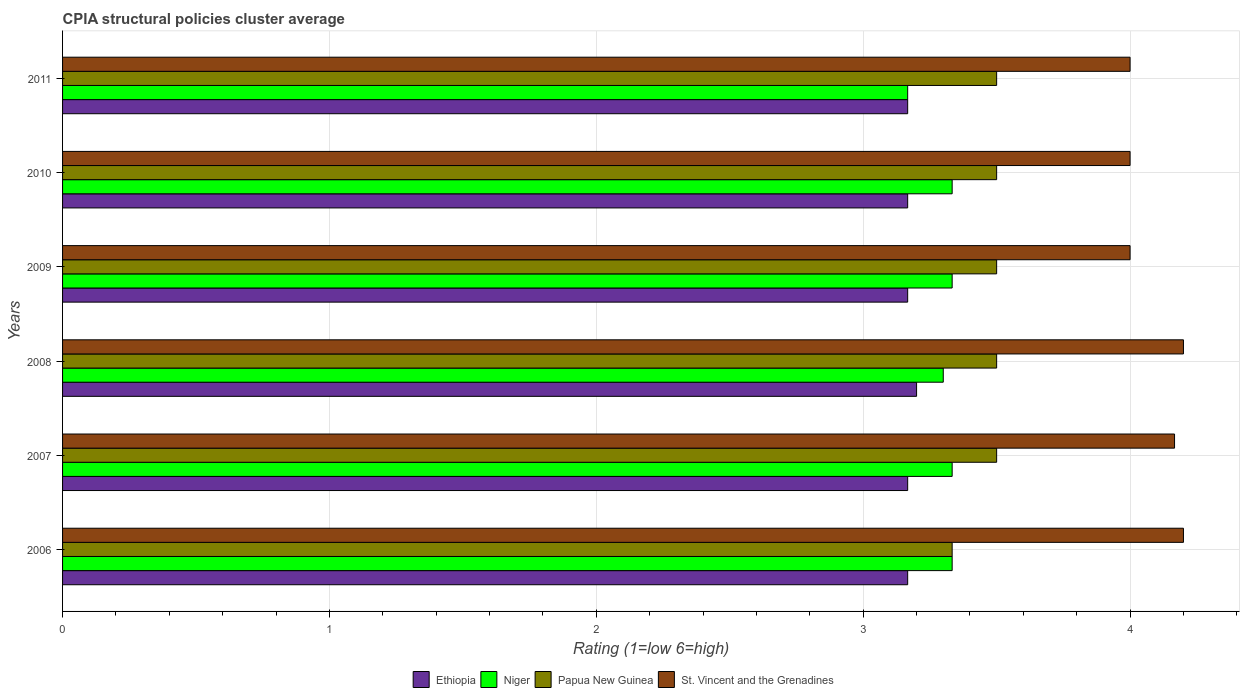How many different coloured bars are there?
Your answer should be compact. 4. What is the label of the 2nd group of bars from the top?
Keep it short and to the point. 2010. What is the CPIA rating in Papua New Guinea in 2006?
Provide a succinct answer. 3.33. Across all years, what is the maximum CPIA rating in Ethiopia?
Your answer should be compact. 3.2. Across all years, what is the minimum CPIA rating in St. Vincent and the Grenadines?
Offer a terse response. 4. In which year was the CPIA rating in Ethiopia maximum?
Your answer should be compact. 2008. In which year was the CPIA rating in St. Vincent and the Grenadines minimum?
Provide a succinct answer. 2009. What is the total CPIA rating in St. Vincent and the Grenadines in the graph?
Ensure brevity in your answer.  24.57. What is the difference between the CPIA rating in St. Vincent and the Grenadines in 2006 and that in 2011?
Keep it short and to the point. 0.2. What is the average CPIA rating in Papua New Guinea per year?
Your answer should be compact. 3.47. In the year 2011, what is the difference between the CPIA rating in Papua New Guinea and CPIA rating in Niger?
Your answer should be very brief. 0.33. In how many years, is the CPIA rating in Ethiopia greater than 2.6 ?
Your answer should be very brief. 6. What is the ratio of the CPIA rating in Papua New Guinea in 2006 to that in 2008?
Offer a very short reply. 0.95. Is the CPIA rating in St. Vincent and the Grenadines in 2008 less than that in 2009?
Provide a short and direct response. No. Is the difference between the CPIA rating in Papua New Guinea in 2009 and 2011 greater than the difference between the CPIA rating in Niger in 2009 and 2011?
Give a very brief answer. No. What is the difference between the highest and the second highest CPIA rating in St. Vincent and the Grenadines?
Provide a succinct answer. 0. What is the difference between the highest and the lowest CPIA rating in St. Vincent and the Grenadines?
Your response must be concise. 0.2. In how many years, is the CPIA rating in Papua New Guinea greater than the average CPIA rating in Papua New Guinea taken over all years?
Offer a terse response. 5. Is the sum of the CPIA rating in Ethiopia in 2007 and 2008 greater than the maximum CPIA rating in St. Vincent and the Grenadines across all years?
Make the answer very short. Yes. What does the 4th bar from the top in 2011 represents?
Ensure brevity in your answer.  Ethiopia. What does the 3rd bar from the bottom in 2006 represents?
Your response must be concise. Papua New Guinea. Is it the case that in every year, the sum of the CPIA rating in St. Vincent and the Grenadines and CPIA rating in Ethiopia is greater than the CPIA rating in Niger?
Give a very brief answer. Yes. What is the difference between two consecutive major ticks on the X-axis?
Give a very brief answer. 1. Are the values on the major ticks of X-axis written in scientific E-notation?
Offer a terse response. No. Does the graph contain any zero values?
Offer a terse response. No. Does the graph contain grids?
Your response must be concise. Yes. Where does the legend appear in the graph?
Offer a very short reply. Bottom center. How many legend labels are there?
Make the answer very short. 4. How are the legend labels stacked?
Make the answer very short. Horizontal. What is the title of the graph?
Provide a short and direct response. CPIA structural policies cluster average. Does "Jordan" appear as one of the legend labels in the graph?
Your response must be concise. No. What is the label or title of the X-axis?
Make the answer very short. Rating (1=low 6=high). What is the label or title of the Y-axis?
Make the answer very short. Years. What is the Rating (1=low 6=high) of Ethiopia in 2006?
Make the answer very short. 3.17. What is the Rating (1=low 6=high) in Niger in 2006?
Ensure brevity in your answer.  3.33. What is the Rating (1=low 6=high) of Papua New Guinea in 2006?
Give a very brief answer. 3.33. What is the Rating (1=low 6=high) in Ethiopia in 2007?
Provide a succinct answer. 3.17. What is the Rating (1=low 6=high) in Niger in 2007?
Give a very brief answer. 3.33. What is the Rating (1=low 6=high) of Papua New Guinea in 2007?
Offer a terse response. 3.5. What is the Rating (1=low 6=high) of St. Vincent and the Grenadines in 2007?
Provide a succinct answer. 4.17. What is the Rating (1=low 6=high) in Papua New Guinea in 2008?
Give a very brief answer. 3.5. What is the Rating (1=low 6=high) of St. Vincent and the Grenadines in 2008?
Your answer should be very brief. 4.2. What is the Rating (1=low 6=high) in Ethiopia in 2009?
Keep it short and to the point. 3.17. What is the Rating (1=low 6=high) of Niger in 2009?
Offer a terse response. 3.33. What is the Rating (1=low 6=high) in Papua New Guinea in 2009?
Your response must be concise. 3.5. What is the Rating (1=low 6=high) of Ethiopia in 2010?
Your answer should be compact. 3.17. What is the Rating (1=low 6=high) of Niger in 2010?
Your answer should be very brief. 3.33. What is the Rating (1=low 6=high) in Papua New Guinea in 2010?
Offer a terse response. 3.5. What is the Rating (1=low 6=high) of Ethiopia in 2011?
Provide a succinct answer. 3.17. What is the Rating (1=low 6=high) of Niger in 2011?
Offer a very short reply. 3.17. Across all years, what is the maximum Rating (1=low 6=high) of Niger?
Ensure brevity in your answer.  3.33. Across all years, what is the maximum Rating (1=low 6=high) of Papua New Guinea?
Your answer should be compact. 3.5. Across all years, what is the maximum Rating (1=low 6=high) in St. Vincent and the Grenadines?
Your response must be concise. 4.2. Across all years, what is the minimum Rating (1=low 6=high) of Ethiopia?
Your response must be concise. 3.17. Across all years, what is the minimum Rating (1=low 6=high) of Niger?
Make the answer very short. 3.17. Across all years, what is the minimum Rating (1=low 6=high) of Papua New Guinea?
Your answer should be very brief. 3.33. Across all years, what is the minimum Rating (1=low 6=high) in St. Vincent and the Grenadines?
Offer a terse response. 4. What is the total Rating (1=low 6=high) of Ethiopia in the graph?
Make the answer very short. 19.03. What is the total Rating (1=low 6=high) in Niger in the graph?
Your answer should be compact. 19.8. What is the total Rating (1=low 6=high) in Papua New Guinea in the graph?
Your answer should be very brief. 20.83. What is the total Rating (1=low 6=high) in St. Vincent and the Grenadines in the graph?
Ensure brevity in your answer.  24.57. What is the difference between the Rating (1=low 6=high) of Ethiopia in 2006 and that in 2007?
Ensure brevity in your answer.  0. What is the difference between the Rating (1=low 6=high) in St. Vincent and the Grenadines in 2006 and that in 2007?
Give a very brief answer. 0.03. What is the difference between the Rating (1=low 6=high) of Ethiopia in 2006 and that in 2008?
Give a very brief answer. -0.03. What is the difference between the Rating (1=low 6=high) of Papua New Guinea in 2006 and that in 2008?
Offer a very short reply. -0.17. What is the difference between the Rating (1=low 6=high) of Niger in 2006 and that in 2009?
Provide a succinct answer. 0. What is the difference between the Rating (1=low 6=high) in Niger in 2006 and that in 2010?
Your answer should be compact. 0. What is the difference between the Rating (1=low 6=high) in Papua New Guinea in 2006 and that in 2010?
Your answer should be very brief. -0.17. What is the difference between the Rating (1=low 6=high) in St. Vincent and the Grenadines in 2006 and that in 2010?
Your response must be concise. 0.2. What is the difference between the Rating (1=low 6=high) of Ethiopia in 2007 and that in 2008?
Give a very brief answer. -0.03. What is the difference between the Rating (1=low 6=high) in Niger in 2007 and that in 2008?
Provide a succinct answer. 0.03. What is the difference between the Rating (1=low 6=high) in Papua New Guinea in 2007 and that in 2008?
Provide a succinct answer. 0. What is the difference between the Rating (1=low 6=high) in St. Vincent and the Grenadines in 2007 and that in 2008?
Provide a succinct answer. -0.03. What is the difference between the Rating (1=low 6=high) of Ethiopia in 2007 and that in 2009?
Your response must be concise. 0. What is the difference between the Rating (1=low 6=high) of Niger in 2007 and that in 2009?
Keep it short and to the point. 0. What is the difference between the Rating (1=low 6=high) in Papua New Guinea in 2007 and that in 2009?
Offer a very short reply. 0. What is the difference between the Rating (1=low 6=high) of St. Vincent and the Grenadines in 2007 and that in 2009?
Keep it short and to the point. 0.17. What is the difference between the Rating (1=low 6=high) in Niger in 2007 and that in 2010?
Offer a very short reply. 0. What is the difference between the Rating (1=low 6=high) in St. Vincent and the Grenadines in 2007 and that in 2010?
Offer a terse response. 0.17. What is the difference between the Rating (1=low 6=high) in Ethiopia in 2007 and that in 2011?
Your answer should be very brief. 0. What is the difference between the Rating (1=low 6=high) in St. Vincent and the Grenadines in 2007 and that in 2011?
Your answer should be compact. 0.17. What is the difference between the Rating (1=low 6=high) in Ethiopia in 2008 and that in 2009?
Offer a terse response. 0.03. What is the difference between the Rating (1=low 6=high) of Niger in 2008 and that in 2009?
Your response must be concise. -0.03. What is the difference between the Rating (1=low 6=high) of Papua New Guinea in 2008 and that in 2009?
Provide a short and direct response. 0. What is the difference between the Rating (1=low 6=high) of St. Vincent and the Grenadines in 2008 and that in 2009?
Offer a very short reply. 0.2. What is the difference between the Rating (1=low 6=high) in Ethiopia in 2008 and that in 2010?
Offer a terse response. 0.03. What is the difference between the Rating (1=low 6=high) in Niger in 2008 and that in 2010?
Your answer should be compact. -0.03. What is the difference between the Rating (1=low 6=high) of Papua New Guinea in 2008 and that in 2010?
Your answer should be compact. 0. What is the difference between the Rating (1=low 6=high) in St. Vincent and the Grenadines in 2008 and that in 2010?
Your response must be concise. 0.2. What is the difference between the Rating (1=low 6=high) in Niger in 2008 and that in 2011?
Your response must be concise. 0.13. What is the difference between the Rating (1=low 6=high) of St. Vincent and the Grenadines in 2008 and that in 2011?
Ensure brevity in your answer.  0.2. What is the difference between the Rating (1=low 6=high) of Ethiopia in 2009 and that in 2010?
Offer a very short reply. 0. What is the difference between the Rating (1=low 6=high) of Niger in 2009 and that in 2010?
Provide a short and direct response. 0. What is the difference between the Rating (1=low 6=high) in Niger in 2009 and that in 2011?
Give a very brief answer. 0.17. What is the difference between the Rating (1=low 6=high) in Papua New Guinea in 2009 and that in 2011?
Your response must be concise. 0. What is the difference between the Rating (1=low 6=high) of St. Vincent and the Grenadines in 2009 and that in 2011?
Offer a very short reply. 0. What is the difference between the Rating (1=low 6=high) of Ethiopia in 2006 and the Rating (1=low 6=high) of St. Vincent and the Grenadines in 2007?
Keep it short and to the point. -1. What is the difference between the Rating (1=low 6=high) in Niger in 2006 and the Rating (1=low 6=high) in Papua New Guinea in 2007?
Provide a succinct answer. -0.17. What is the difference between the Rating (1=low 6=high) of Niger in 2006 and the Rating (1=low 6=high) of St. Vincent and the Grenadines in 2007?
Provide a succinct answer. -0.83. What is the difference between the Rating (1=low 6=high) in Papua New Guinea in 2006 and the Rating (1=low 6=high) in St. Vincent and the Grenadines in 2007?
Provide a succinct answer. -0.83. What is the difference between the Rating (1=low 6=high) in Ethiopia in 2006 and the Rating (1=low 6=high) in Niger in 2008?
Keep it short and to the point. -0.13. What is the difference between the Rating (1=low 6=high) of Ethiopia in 2006 and the Rating (1=low 6=high) of St. Vincent and the Grenadines in 2008?
Your response must be concise. -1.03. What is the difference between the Rating (1=low 6=high) in Niger in 2006 and the Rating (1=low 6=high) in St. Vincent and the Grenadines in 2008?
Offer a very short reply. -0.87. What is the difference between the Rating (1=low 6=high) of Papua New Guinea in 2006 and the Rating (1=low 6=high) of St. Vincent and the Grenadines in 2008?
Your response must be concise. -0.87. What is the difference between the Rating (1=low 6=high) in Ethiopia in 2006 and the Rating (1=low 6=high) in Papua New Guinea in 2009?
Offer a terse response. -0.33. What is the difference between the Rating (1=low 6=high) of Papua New Guinea in 2006 and the Rating (1=low 6=high) of St. Vincent and the Grenadines in 2009?
Provide a succinct answer. -0.67. What is the difference between the Rating (1=low 6=high) in Ethiopia in 2006 and the Rating (1=low 6=high) in Niger in 2010?
Make the answer very short. -0.17. What is the difference between the Rating (1=low 6=high) of Ethiopia in 2006 and the Rating (1=low 6=high) of Papua New Guinea in 2010?
Provide a succinct answer. -0.33. What is the difference between the Rating (1=low 6=high) in Ethiopia in 2006 and the Rating (1=low 6=high) in St. Vincent and the Grenadines in 2010?
Your response must be concise. -0.83. What is the difference between the Rating (1=low 6=high) of Niger in 2006 and the Rating (1=low 6=high) of St. Vincent and the Grenadines in 2010?
Provide a succinct answer. -0.67. What is the difference between the Rating (1=low 6=high) of Niger in 2006 and the Rating (1=low 6=high) of St. Vincent and the Grenadines in 2011?
Keep it short and to the point. -0.67. What is the difference between the Rating (1=low 6=high) in Ethiopia in 2007 and the Rating (1=low 6=high) in Niger in 2008?
Give a very brief answer. -0.13. What is the difference between the Rating (1=low 6=high) of Ethiopia in 2007 and the Rating (1=low 6=high) of Papua New Guinea in 2008?
Provide a short and direct response. -0.33. What is the difference between the Rating (1=low 6=high) of Ethiopia in 2007 and the Rating (1=low 6=high) of St. Vincent and the Grenadines in 2008?
Offer a terse response. -1.03. What is the difference between the Rating (1=low 6=high) of Niger in 2007 and the Rating (1=low 6=high) of St. Vincent and the Grenadines in 2008?
Offer a very short reply. -0.87. What is the difference between the Rating (1=low 6=high) in Ethiopia in 2007 and the Rating (1=low 6=high) in Papua New Guinea in 2009?
Offer a very short reply. -0.33. What is the difference between the Rating (1=low 6=high) of Niger in 2007 and the Rating (1=low 6=high) of Papua New Guinea in 2009?
Provide a succinct answer. -0.17. What is the difference between the Rating (1=low 6=high) of Ethiopia in 2007 and the Rating (1=low 6=high) of St. Vincent and the Grenadines in 2010?
Give a very brief answer. -0.83. What is the difference between the Rating (1=low 6=high) in Papua New Guinea in 2007 and the Rating (1=low 6=high) in St. Vincent and the Grenadines in 2010?
Your answer should be very brief. -0.5. What is the difference between the Rating (1=low 6=high) of Ethiopia in 2007 and the Rating (1=low 6=high) of Niger in 2011?
Offer a terse response. 0. What is the difference between the Rating (1=low 6=high) in Niger in 2007 and the Rating (1=low 6=high) in St. Vincent and the Grenadines in 2011?
Offer a terse response. -0.67. What is the difference between the Rating (1=low 6=high) of Ethiopia in 2008 and the Rating (1=low 6=high) of Niger in 2009?
Ensure brevity in your answer.  -0.13. What is the difference between the Rating (1=low 6=high) in Ethiopia in 2008 and the Rating (1=low 6=high) in Niger in 2010?
Make the answer very short. -0.13. What is the difference between the Rating (1=low 6=high) of Ethiopia in 2008 and the Rating (1=low 6=high) of St. Vincent and the Grenadines in 2010?
Your answer should be compact. -0.8. What is the difference between the Rating (1=low 6=high) of Niger in 2008 and the Rating (1=low 6=high) of St. Vincent and the Grenadines in 2010?
Your answer should be compact. -0.7. What is the difference between the Rating (1=low 6=high) of Ethiopia in 2008 and the Rating (1=low 6=high) of Niger in 2011?
Give a very brief answer. 0.03. What is the difference between the Rating (1=low 6=high) in Ethiopia in 2008 and the Rating (1=low 6=high) in Papua New Guinea in 2011?
Your answer should be compact. -0.3. What is the difference between the Rating (1=low 6=high) in Ethiopia in 2008 and the Rating (1=low 6=high) in St. Vincent and the Grenadines in 2011?
Make the answer very short. -0.8. What is the difference between the Rating (1=low 6=high) in Niger in 2008 and the Rating (1=low 6=high) in St. Vincent and the Grenadines in 2011?
Give a very brief answer. -0.7. What is the difference between the Rating (1=low 6=high) of Papua New Guinea in 2008 and the Rating (1=low 6=high) of St. Vincent and the Grenadines in 2011?
Give a very brief answer. -0.5. What is the difference between the Rating (1=low 6=high) in Ethiopia in 2009 and the Rating (1=low 6=high) in Papua New Guinea in 2010?
Your answer should be very brief. -0.33. What is the difference between the Rating (1=low 6=high) in Niger in 2009 and the Rating (1=low 6=high) in Papua New Guinea in 2010?
Provide a short and direct response. -0.17. What is the difference between the Rating (1=low 6=high) of Ethiopia in 2009 and the Rating (1=low 6=high) of Niger in 2011?
Provide a succinct answer. 0. What is the difference between the Rating (1=low 6=high) in Ethiopia in 2009 and the Rating (1=low 6=high) in Papua New Guinea in 2011?
Make the answer very short. -0.33. What is the difference between the Rating (1=low 6=high) of Papua New Guinea in 2009 and the Rating (1=low 6=high) of St. Vincent and the Grenadines in 2011?
Provide a short and direct response. -0.5. What is the difference between the Rating (1=low 6=high) in Ethiopia in 2010 and the Rating (1=low 6=high) in Niger in 2011?
Give a very brief answer. 0. What is the difference between the Rating (1=low 6=high) in Ethiopia in 2010 and the Rating (1=low 6=high) in Papua New Guinea in 2011?
Provide a short and direct response. -0.33. What is the difference between the Rating (1=low 6=high) in Ethiopia in 2010 and the Rating (1=low 6=high) in St. Vincent and the Grenadines in 2011?
Provide a succinct answer. -0.83. What is the difference between the Rating (1=low 6=high) in Niger in 2010 and the Rating (1=low 6=high) in St. Vincent and the Grenadines in 2011?
Give a very brief answer. -0.67. What is the difference between the Rating (1=low 6=high) in Papua New Guinea in 2010 and the Rating (1=low 6=high) in St. Vincent and the Grenadines in 2011?
Offer a very short reply. -0.5. What is the average Rating (1=low 6=high) of Ethiopia per year?
Your response must be concise. 3.17. What is the average Rating (1=low 6=high) in Papua New Guinea per year?
Provide a short and direct response. 3.47. What is the average Rating (1=low 6=high) in St. Vincent and the Grenadines per year?
Keep it short and to the point. 4.09. In the year 2006, what is the difference between the Rating (1=low 6=high) in Ethiopia and Rating (1=low 6=high) in St. Vincent and the Grenadines?
Keep it short and to the point. -1.03. In the year 2006, what is the difference between the Rating (1=low 6=high) of Niger and Rating (1=low 6=high) of St. Vincent and the Grenadines?
Keep it short and to the point. -0.87. In the year 2006, what is the difference between the Rating (1=low 6=high) in Papua New Guinea and Rating (1=low 6=high) in St. Vincent and the Grenadines?
Your answer should be very brief. -0.87. In the year 2007, what is the difference between the Rating (1=low 6=high) in Ethiopia and Rating (1=low 6=high) in St. Vincent and the Grenadines?
Offer a terse response. -1. In the year 2007, what is the difference between the Rating (1=low 6=high) of Niger and Rating (1=low 6=high) of St. Vincent and the Grenadines?
Your answer should be compact. -0.83. In the year 2008, what is the difference between the Rating (1=low 6=high) of Ethiopia and Rating (1=low 6=high) of Niger?
Ensure brevity in your answer.  -0.1. In the year 2008, what is the difference between the Rating (1=low 6=high) in Ethiopia and Rating (1=low 6=high) in Papua New Guinea?
Make the answer very short. -0.3. In the year 2008, what is the difference between the Rating (1=low 6=high) in Ethiopia and Rating (1=low 6=high) in St. Vincent and the Grenadines?
Make the answer very short. -1. In the year 2008, what is the difference between the Rating (1=low 6=high) of Niger and Rating (1=low 6=high) of St. Vincent and the Grenadines?
Make the answer very short. -0.9. In the year 2008, what is the difference between the Rating (1=low 6=high) in Papua New Guinea and Rating (1=low 6=high) in St. Vincent and the Grenadines?
Your answer should be very brief. -0.7. In the year 2009, what is the difference between the Rating (1=low 6=high) in Niger and Rating (1=low 6=high) in St. Vincent and the Grenadines?
Provide a short and direct response. -0.67. In the year 2010, what is the difference between the Rating (1=low 6=high) of Ethiopia and Rating (1=low 6=high) of St. Vincent and the Grenadines?
Make the answer very short. -0.83. In the year 2010, what is the difference between the Rating (1=low 6=high) in Papua New Guinea and Rating (1=low 6=high) in St. Vincent and the Grenadines?
Offer a very short reply. -0.5. In the year 2011, what is the difference between the Rating (1=low 6=high) in Ethiopia and Rating (1=low 6=high) in Niger?
Provide a short and direct response. 0. In the year 2011, what is the difference between the Rating (1=low 6=high) in Ethiopia and Rating (1=low 6=high) in Papua New Guinea?
Give a very brief answer. -0.33. In the year 2011, what is the difference between the Rating (1=low 6=high) in Ethiopia and Rating (1=low 6=high) in St. Vincent and the Grenadines?
Provide a short and direct response. -0.83. In the year 2011, what is the difference between the Rating (1=low 6=high) in Niger and Rating (1=low 6=high) in St. Vincent and the Grenadines?
Make the answer very short. -0.83. In the year 2011, what is the difference between the Rating (1=low 6=high) of Papua New Guinea and Rating (1=low 6=high) of St. Vincent and the Grenadines?
Provide a short and direct response. -0.5. What is the ratio of the Rating (1=low 6=high) of Ethiopia in 2006 to that in 2007?
Provide a short and direct response. 1. What is the ratio of the Rating (1=low 6=high) of Ethiopia in 2006 to that in 2008?
Your answer should be compact. 0.99. What is the ratio of the Rating (1=low 6=high) of Papua New Guinea in 2006 to that in 2008?
Ensure brevity in your answer.  0.95. What is the ratio of the Rating (1=low 6=high) in St. Vincent and the Grenadines in 2006 to that in 2008?
Ensure brevity in your answer.  1. What is the ratio of the Rating (1=low 6=high) in Ethiopia in 2006 to that in 2009?
Your answer should be very brief. 1. What is the ratio of the Rating (1=low 6=high) of Niger in 2006 to that in 2009?
Your answer should be compact. 1. What is the ratio of the Rating (1=low 6=high) of Papua New Guinea in 2006 to that in 2009?
Give a very brief answer. 0.95. What is the ratio of the Rating (1=low 6=high) in Ethiopia in 2006 to that in 2010?
Offer a very short reply. 1. What is the ratio of the Rating (1=low 6=high) of Papua New Guinea in 2006 to that in 2010?
Give a very brief answer. 0.95. What is the ratio of the Rating (1=low 6=high) of St. Vincent and the Grenadines in 2006 to that in 2010?
Provide a short and direct response. 1.05. What is the ratio of the Rating (1=low 6=high) in Ethiopia in 2006 to that in 2011?
Your response must be concise. 1. What is the ratio of the Rating (1=low 6=high) in Niger in 2006 to that in 2011?
Keep it short and to the point. 1.05. What is the ratio of the Rating (1=low 6=high) of Papua New Guinea in 2006 to that in 2011?
Offer a terse response. 0.95. What is the ratio of the Rating (1=low 6=high) in St. Vincent and the Grenadines in 2006 to that in 2011?
Your response must be concise. 1.05. What is the ratio of the Rating (1=low 6=high) of Ethiopia in 2007 to that in 2008?
Make the answer very short. 0.99. What is the ratio of the Rating (1=low 6=high) in Niger in 2007 to that in 2008?
Provide a short and direct response. 1.01. What is the ratio of the Rating (1=low 6=high) of Ethiopia in 2007 to that in 2009?
Provide a short and direct response. 1. What is the ratio of the Rating (1=low 6=high) in Niger in 2007 to that in 2009?
Provide a succinct answer. 1. What is the ratio of the Rating (1=low 6=high) of Papua New Guinea in 2007 to that in 2009?
Your answer should be very brief. 1. What is the ratio of the Rating (1=low 6=high) of St. Vincent and the Grenadines in 2007 to that in 2009?
Make the answer very short. 1.04. What is the ratio of the Rating (1=low 6=high) in Niger in 2007 to that in 2010?
Ensure brevity in your answer.  1. What is the ratio of the Rating (1=low 6=high) of St. Vincent and the Grenadines in 2007 to that in 2010?
Make the answer very short. 1.04. What is the ratio of the Rating (1=low 6=high) of Niger in 2007 to that in 2011?
Provide a succinct answer. 1.05. What is the ratio of the Rating (1=low 6=high) of Papua New Guinea in 2007 to that in 2011?
Make the answer very short. 1. What is the ratio of the Rating (1=low 6=high) in St. Vincent and the Grenadines in 2007 to that in 2011?
Give a very brief answer. 1.04. What is the ratio of the Rating (1=low 6=high) in Ethiopia in 2008 to that in 2009?
Offer a terse response. 1.01. What is the ratio of the Rating (1=low 6=high) of Niger in 2008 to that in 2009?
Your answer should be compact. 0.99. What is the ratio of the Rating (1=low 6=high) in St. Vincent and the Grenadines in 2008 to that in 2009?
Provide a succinct answer. 1.05. What is the ratio of the Rating (1=low 6=high) in Ethiopia in 2008 to that in 2010?
Provide a succinct answer. 1.01. What is the ratio of the Rating (1=low 6=high) of Niger in 2008 to that in 2010?
Your answer should be compact. 0.99. What is the ratio of the Rating (1=low 6=high) in Ethiopia in 2008 to that in 2011?
Keep it short and to the point. 1.01. What is the ratio of the Rating (1=low 6=high) of Niger in 2008 to that in 2011?
Offer a very short reply. 1.04. What is the ratio of the Rating (1=low 6=high) in Papua New Guinea in 2008 to that in 2011?
Your response must be concise. 1. What is the ratio of the Rating (1=low 6=high) in Papua New Guinea in 2009 to that in 2010?
Offer a terse response. 1. What is the ratio of the Rating (1=low 6=high) of Ethiopia in 2009 to that in 2011?
Ensure brevity in your answer.  1. What is the ratio of the Rating (1=low 6=high) of Niger in 2009 to that in 2011?
Provide a short and direct response. 1.05. What is the ratio of the Rating (1=low 6=high) in Papua New Guinea in 2009 to that in 2011?
Provide a succinct answer. 1. What is the ratio of the Rating (1=low 6=high) in Niger in 2010 to that in 2011?
Provide a succinct answer. 1.05. What is the ratio of the Rating (1=low 6=high) in St. Vincent and the Grenadines in 2010 to that in 2011?
Your response must be concise. 1. What is the difference between the highest and the second highest Rating (1=low 6=high) in Ethiopia?
Offer a terse response. 0.03. What is the difference between the highest and the second highest Rating (1=low 6=high) in St. Vincent and the Grenadines?
Make the answer very short. 0. What is the difference between the highest and the lowest Rating (1=low 6=high) in Ethiopia?
Make the answer very short. 0.03. What is the difference between the highest and the lowest Rating (1=low 6=high) of Papua New Guinea?
Ensure brevity in your answer.  0.17. What is the difference between the highest and the lowest Rating (1=low 6=high) of St. Vincent and the Grenadines?
Give a very brief answer. 0.2. 